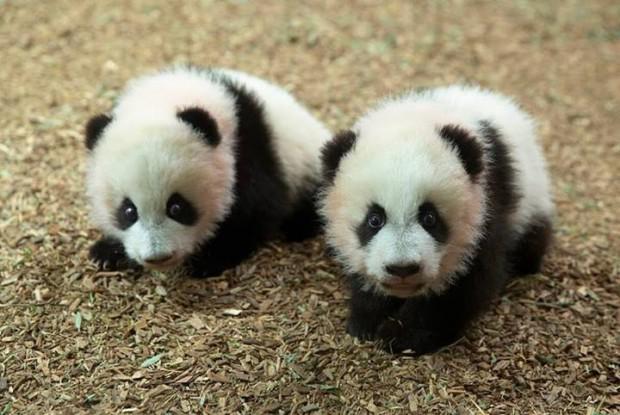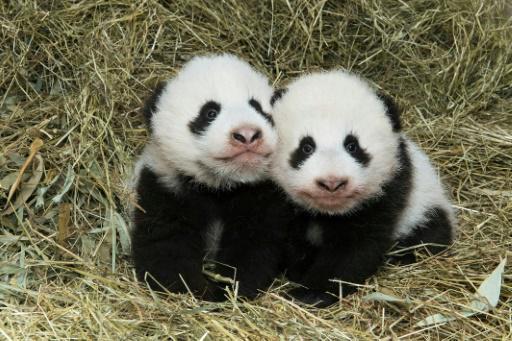The first image is the image on the left, the second image is the image on the right. For the images shown, is this caption "There is at least one baby panda on top of grass looking forward" true? Answer yes or no. Yes. The first image is the image on the left, the second image is the image on the right. Considering the images on both sides, is "There are no panda-pups in the left image." valid? Answer yes or no. No. 